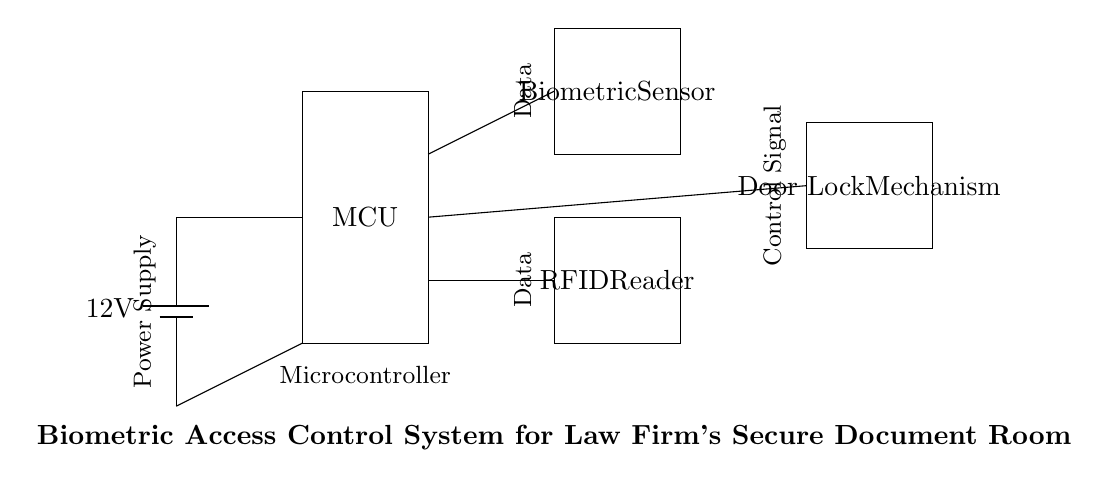What is the voltage of the power supply? The voltage of the power supply is indicated in the circuit as 12V, which is the potential difference provided by the battery.
Answer: 12V What component is connected directly to the battery? The power supply connects directly to the microcontroller, as shown by the line drawn from the battery to the microcontroller.
Answer: Microcontroller How many main components are in the circuit? The circuit includes four main components: the power supply, microcontroller, biometric sensor, and RFID reader.
Answer: Four What signal does the microcontroller send to the door lock mechanism? The microcontroller sends a control signal to the door lock mechanism, which is indicated by the connection from the microcontroller to the door lock in the circuit.
Answer: Control Signal What does the biometric sensor do in this circuit? The biometric sensor processes data from users to authenticate access, as indicated by its labeling in the circuit diagram.
Answer: Authenticate Access Which component receives data from the microcontroller? The RFID reader receives data from the microcontroller, as shown by the connecting line that represents data flow from the microcontroller to the RFID reader.
Answer: RFID Reader 